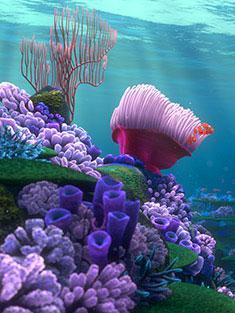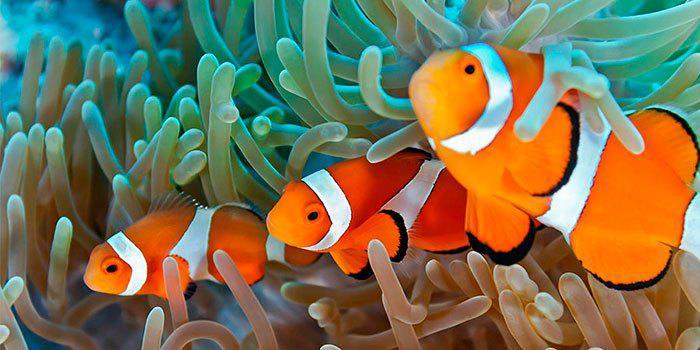The first image is the image on the left, the second image is the image on the right. Evaluate the accuracy of this statement regarding the images: "The left image features an anemone with a wide violet-colored stalk, and the right image shows multiple leftward-turned clownfish swimming among anemone tendrils.". Is it true? Answer yes or no. Yes. The first image is the image on the left, the second image is the image on the right. For the images displayed, is the sentence "There are three clownfish next to a sea anemone in the right image" factually correct? Answer yes or no. Yes. 